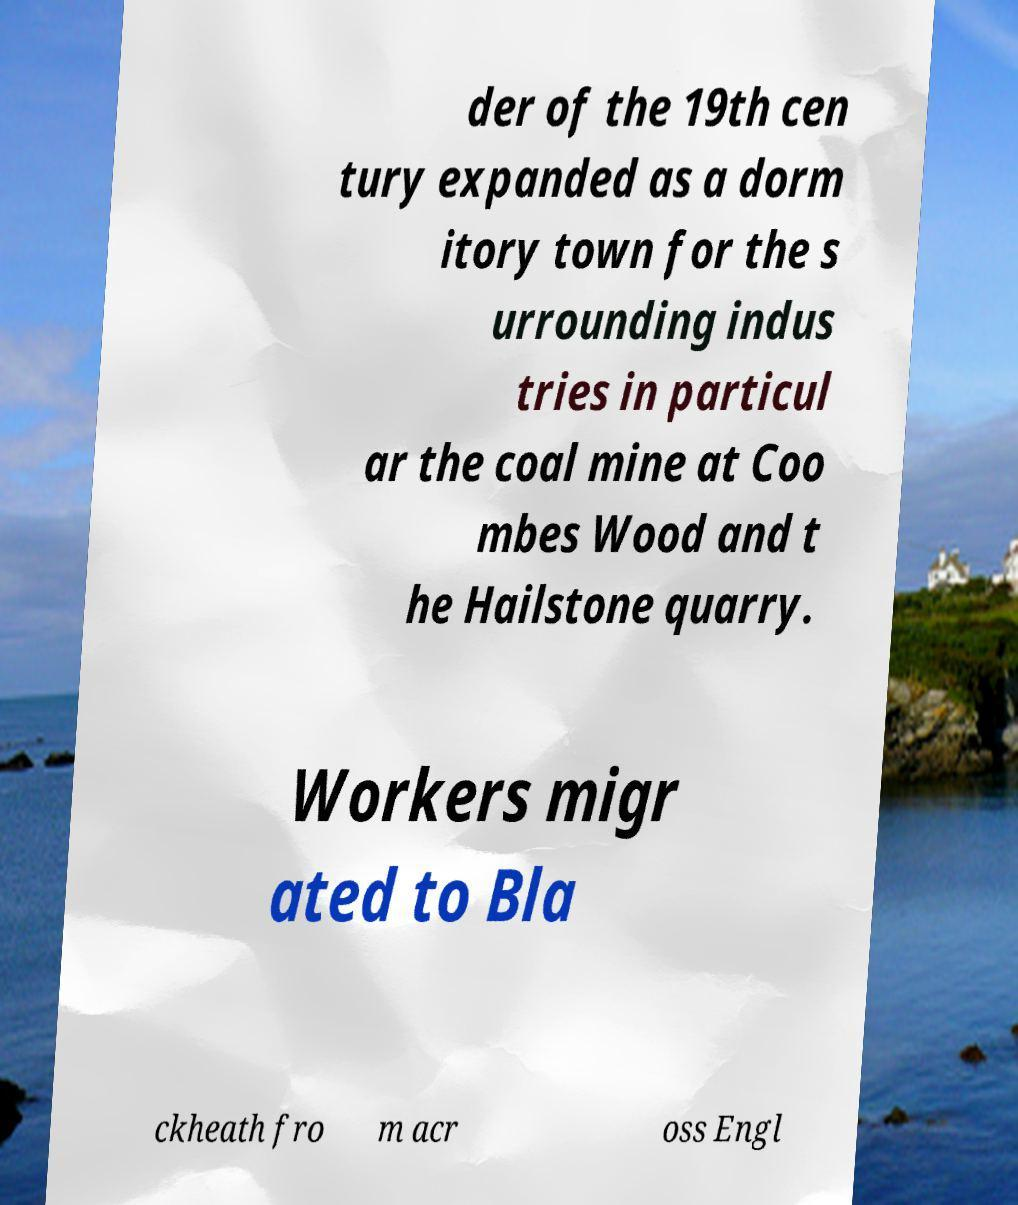Could you assist in decoding the text presented in this image and type it out clearly? der of the 19th cen tury expanded as a dorm itory town for the s urrounding indus tries in particul ar the coal mine at Coo mbes Wood and t he Hailstone quarry. Workers migr ated to Bla ckheath fro m acr oss Engl 